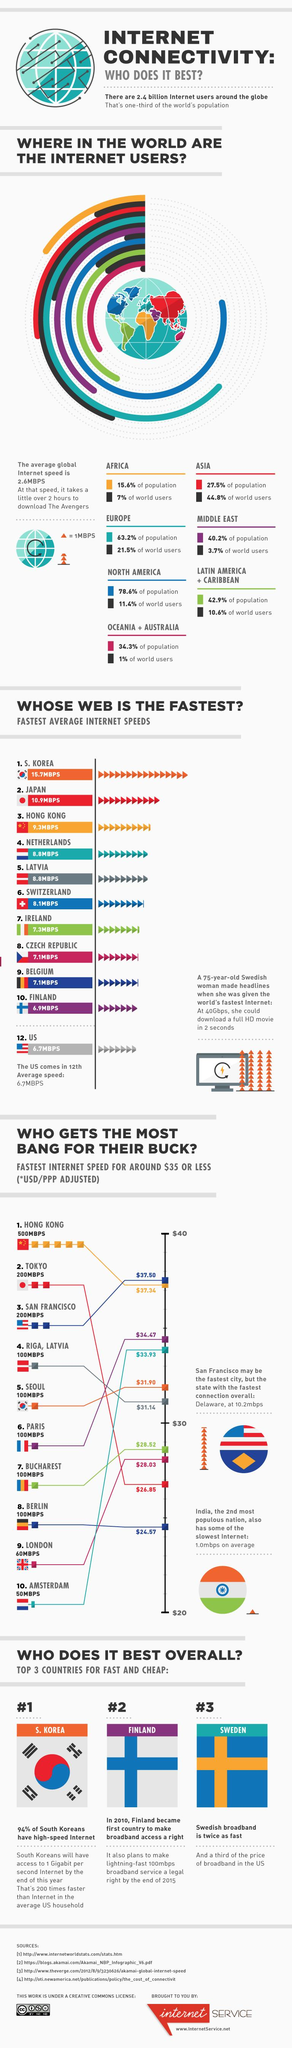Outline some significant characteristics in this image. The global internet penetration rate is extremely low, with only 1% of the world's population having access to the internet. The city with the second highest internet speed and the second lowest internet charges is Tokyo. The highest percentage of population in the world is 78.6%. Europe has the highest percentage of internet users in the world. The cities of Hong Kong, Tokyo, and San Francisco all have internet speeds exceeding 100 megabits per second. 